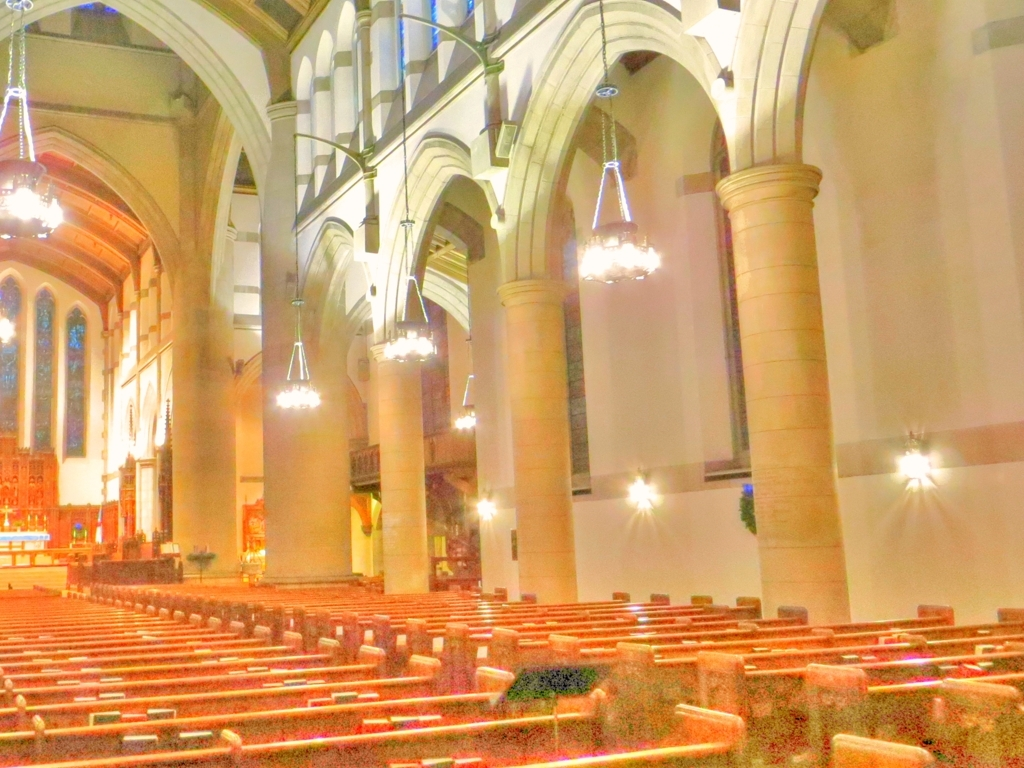Are the features of the pillars and walls relatively clear? The details of the pillars and walls are well-defined and the photograph captures their structure clearly. The pillars are smooth and rounded, rising to meet the vaulted ceiling, while the stone walls bear subtle details in their craftsmanship. The warm lighting enhances the visibility of these features, contributing to the overall clarity of the architectural elements. 